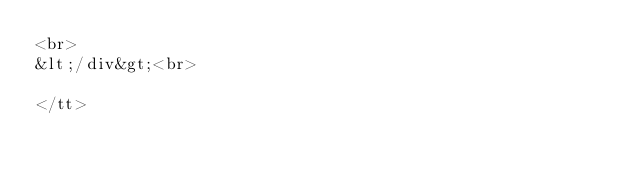Convert code to text. <code><loc_0><loc_0><loc_500><loc_500><_HTML_><br>
&lt;/div&gt;<br>

</tt>
</code> 